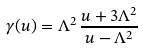<formula> <loc_0><loc_0><loc_500><loc_500>\gamma ( u ) = \Lambda ^ { 2 } \, \frac { u + 3 \Lambda ^ { 2 } } { u - \Lambda ^ { 2 } }</formula> 